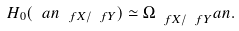<formula> <loc_0><loc_0><loc_500><loc_500>H _ { 0 } ( \L ^ { \ } a n _ { \ f X / \ f Y } ) \simeq \Omega _ { \ f X / \ f Y } ^ { \ } a n .</formula> 